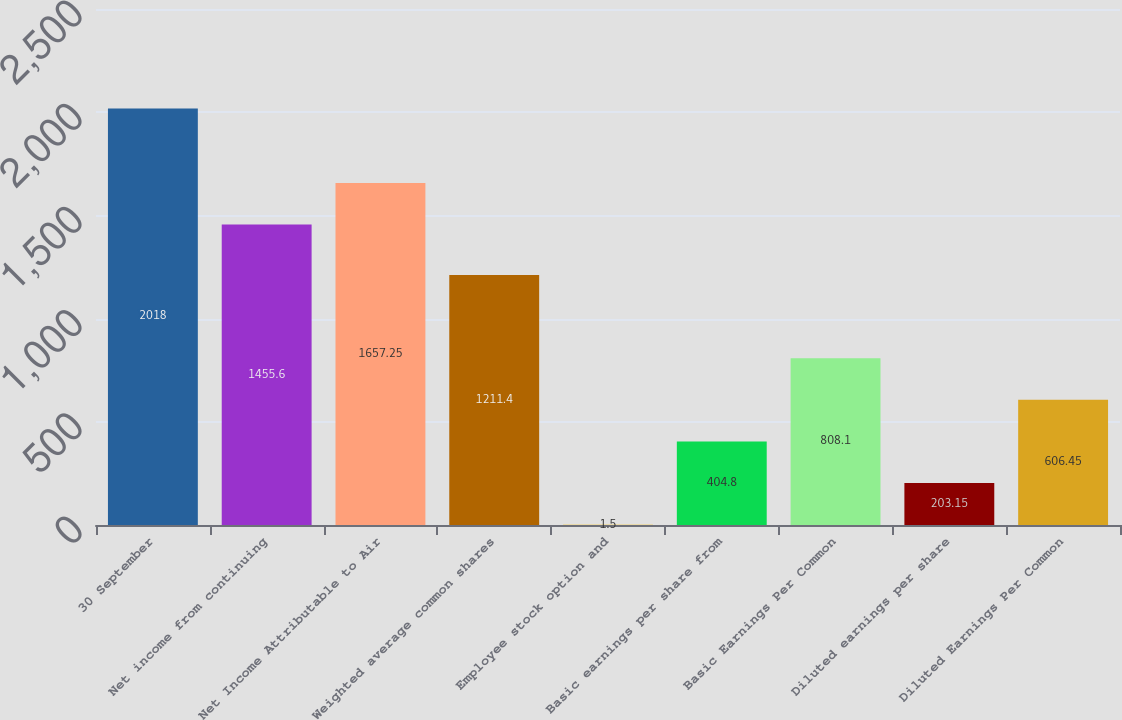Convert chart to OTSL. <chart><loc_0><loc_0><loc_500><loc_500><bar_chart><fcel>30 September<fcel>Net income from continuing<fcel>Net Income Attributable to Air<fcel>Weighted average common shares<fcel>Employee stock option and<fcel>Basic earnings per share from<fcel>Basic Earnings Per Common<fcel>Diluted earnings per share<fcel>Diluted Earnings Per Common<nl><fcel>2018<fcel>1455.6<fcel>1657.25<fcel>1211.4<fcel>1.5<fcel>404.8<fcel>808.1<fcel>203.15<fcel>606.45<nl></chart> 